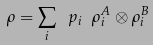<formula> <loc_0><loc_0><loc_500><loc_500>\rho = \sum _ { i } \ p _ { i } \ \rho _ { i } ^ { A } \otimes \rho _ { i } ^ { B }</formula> 